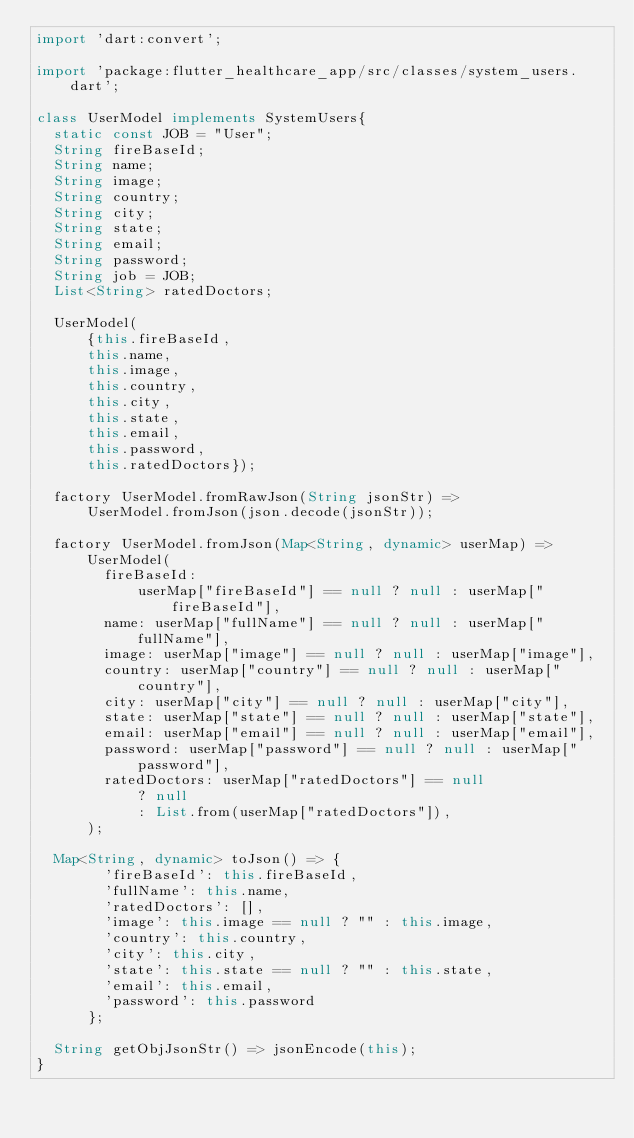<code> <loc_0><loc_0><loc_500><loc_500><_Dart_>import 'dart:convert';

import 'package:flutter_healthcare_app/src/classes/system_users.dart';

class UserModel implements SystemUsers{
  static const JOB = "User";
  String fireBaseId;
  String name;
  String image;
  String country;
  String city;
  String state;
  String email;
  String password;
  String job = JOB;
  List<String> ratedDoctors;

  UserModel(
      {this.fireBaseId,
      this.name,
      this.image,
      this.country,
      this.city,
      this.state,
      this.email,
      this.password,
      this.ratedDoctors});

  factory UserModel.fromRawJson(String jsonStr) =>
      UserModel.fromJson(json.decode(jsonStr));

  factory UserModel.fromJson(Map<String, dynamic> userMap) => UserModel(
        fireBaseId:
            userMap["fireBaseId"] == null ? null : userMap["fireBaseId"],
        name: userMap["fullName"] == null ? null : userMap["fullName"],
        image: userMap["image"] == null ? null : userMap["image"],
        country: userMap["country"] == null ? null : userMap["country"],
        city: userMap["city"] == null ? null : userMap["city"],
        state: userMap["state"] == null ? null : userMap["state"],
        email: userMap["email"] == null ? null : userMap["email"],
        password: userMap["password"] == null ? null : userMap["password"],
        ratedDoctors: userMap["ratedDoctors"] == null
            ? null
            : List.from(userMap["ratedDoctors"]),
      );

  Map<String, dynamic> toJson() => {
        'fireBaseId': this.fireBaseId,
        'fullName': this.name,
        'ratedDoctors': [],
        'image': this.image == null ? "" : this.image,
        'country': this.country,
        'city': this.city,
        'state': this.state == null ? "" : this.state,
        'email': this.email,
        'password': this.password
      };

  String getObjJsonStr() => jsonEncode(this);
}
</code> 